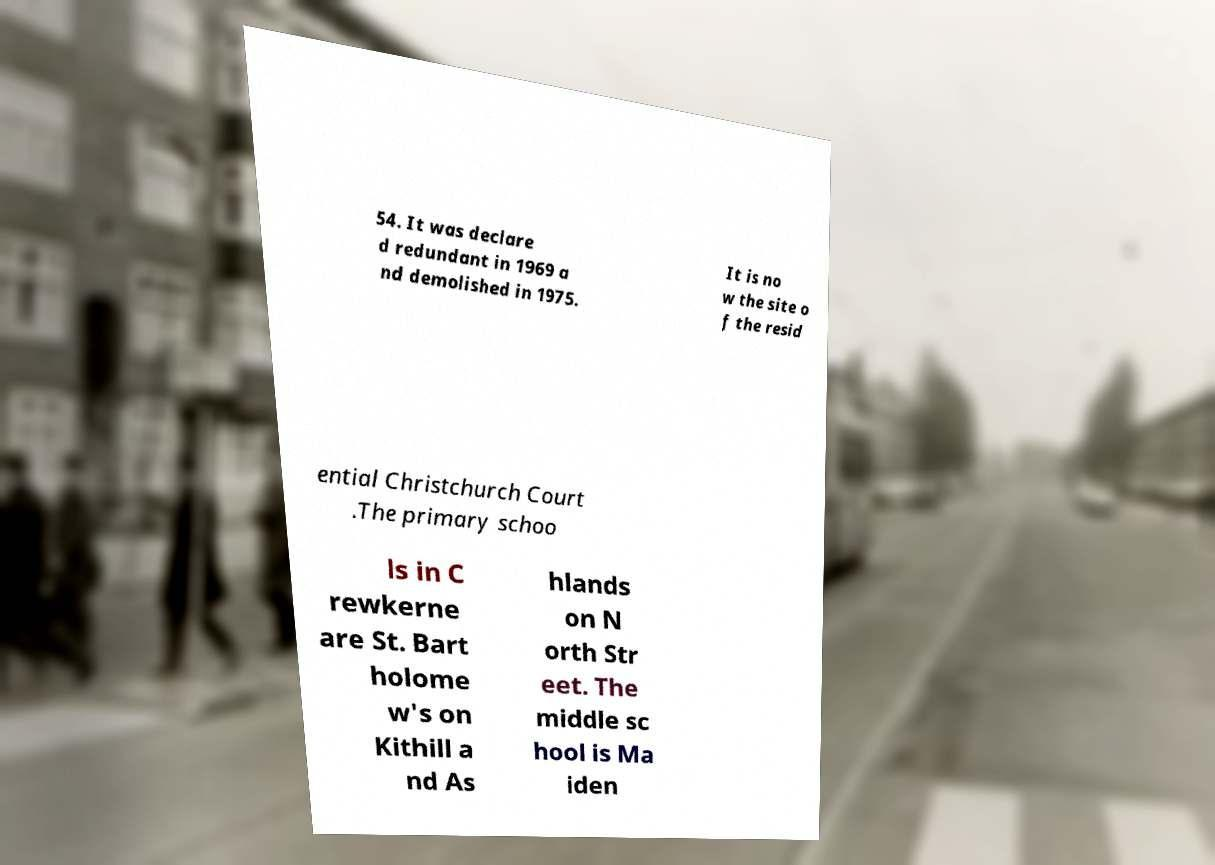Please identify and transcribe the text found in this image. 54. It was declare d redundant in 1969 a nd demolished in 1975. It is no w the site o f the resid ential Christchurch Court .The primary schoo ls in C rewkerne are St. Bart holome w's on Kithill a nd As hlands on N orth Str eet. The middle sc hool is Ma iden 